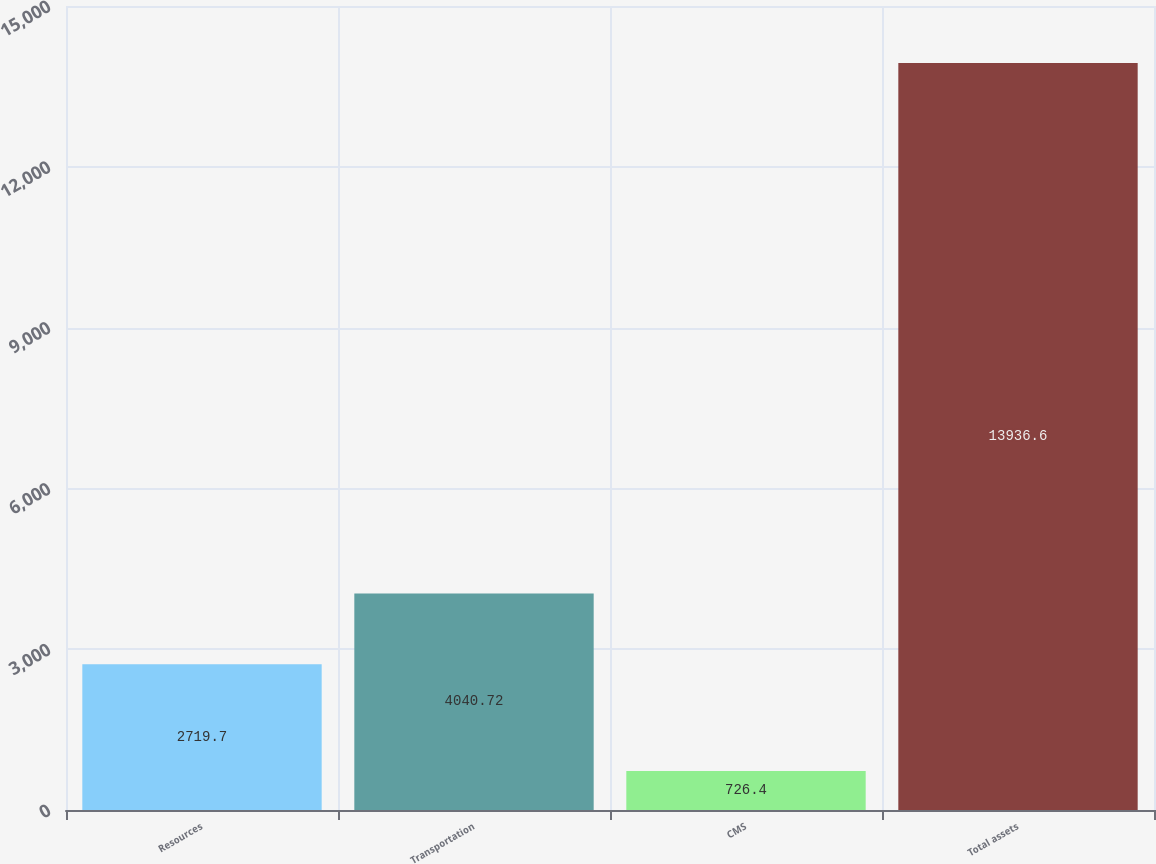Convert chart. <chart><loc_0><loc_0><loc_500><loc_500><bar_chart><fcel>Resources<fcel>Transportation<fcel>CMS<fcel>Total assets<nl><fcel>2719.7<fcel>4040.72<fcel>726.4<fcel>13936.6<nl></chart> 